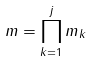<formula> <loc_0><loc_0><loc_500><loc_500>m = \prod _ { k = 1 } ^ { j } m _ { k }</formula> 